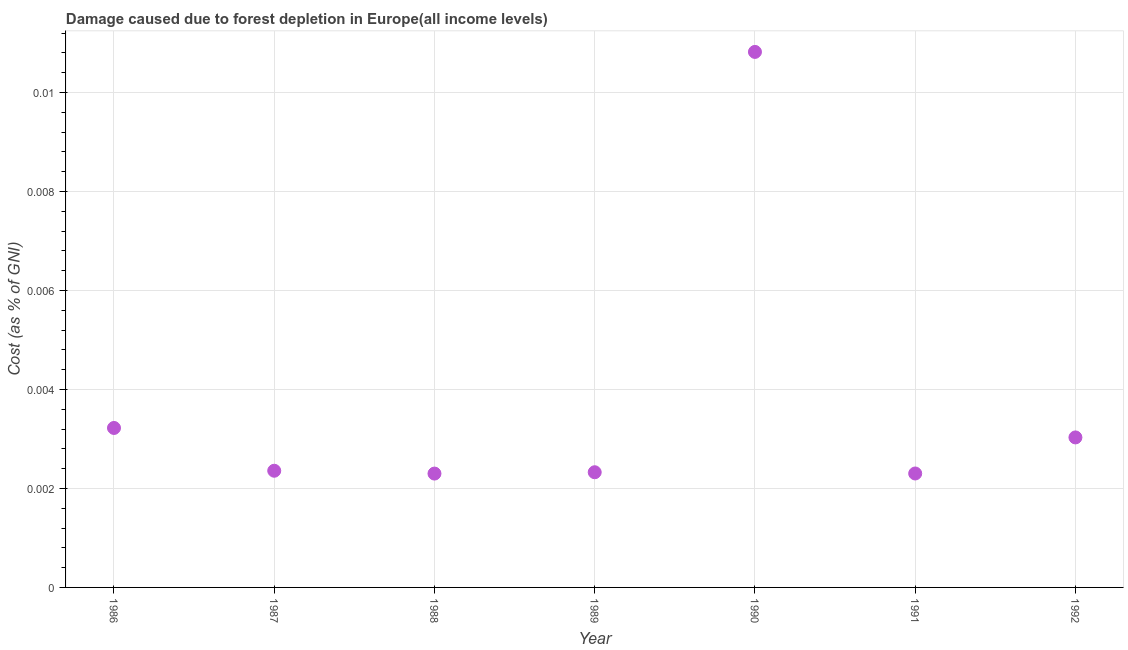What is the damage caused due to forest depletion in 1986?
Your answer should be compact. 0. Across all years, what is the maximum damage caused due to forest depletion?
Give a very brief answer. 0.01. Across all years, what is the minimum damage caused due to forest depletion?
Your response must be concise. 0. In which year was the damage caused due to forest depletion minimum?
Offer a terse response. 1988. What is the sum of the damage caused due to forest depletion?
Your answer should be compact. 0.03. What is the difference between the damage caused due to forest depletion in 1987 and 1991?
Keep it short and to the point. 5.546232632552004e-5. What is the average damage caused due to forest depletion per year?
Provide a succinct answer. 0. What is the median damage caused due to forest depletion?
Provide a short and direct response. 0. What is the ratio of the damage caused due to forest depletion in 1986 to that in 1987?
Your response must be concise. 1.37. What is the difference between the highest and the second highest damage caused due to forest depletion?
Keep it short and to the point. 0.01. Is the sum of the damage caused due to forest depletion in 1986 and 1988 greater than the maximum damage caused due to forest depletion across all years?
Offer a terse response. No. What is the difference between the highest and the lowest damage caused due to forest depletion?
Offer a very short reply. 0.01. How many dotlines are there?
Your answer should be very brief. 1. How many years are there in the graph?
Provide a succinct answer. 7. What is the difference between two consecutive major ticks on the Y-axis?
Your answer should be very brief. 0. Are the values on the major ticks of Y-axis written in scientific E-notation?
Keep it short and to the point. No. Does the graph contain any zero values?
Your response must be concise. No. Does the graph contain grids?
Keep it short and to the point. Yes. What is the title of the graph?
Ensure brevity in your answer.  Damage caused due to forest depletion in Europe(all income levels). What is the label or title of the X-axis?
Offer a terse response. Year. What is the label or title of the Y-axis?
Keep it short and to the point. Cost (as % of GNI). What is the Cost (as % of GNI) in 1986?
Provide a succinct answer. 0. What is the Cost (as % of GNI) in 1987?
Offer a terse response. 0. What is the Cost (as % of GNI) in 1988?
Make the answer very short. 0. What is the Cost (as % of GNI) in 1989?
Provide a short and direct response. 0. What is the Cost (as % of GNI) in 1990?
Provide a short and direct response. 0.01. What is the Cost (as % of GNI) in 1991?
Your answer should be very brief. 0. What is the Cost (as % of GNI) in 1992?
Give a very brief answer. 0. What is the difference between the Cost (as % of GNI) in 1986 and 1987?
Your response must be concise. 0. What is the difference between the Cost (as % of GNI) in 1986 and 1988?
Give a very brief answer. 0. What is the difference between the Cost (as % of GNI) in 1986 and 1989?
Give a very brief answer. 0. What is the difference between the Cost (as % of GNI) in 1986 and 1990?
Offer a very short reply. -0.01. What is the difference between the Cost (as % of GNI) in 1986 and 1991?
Your response must be concise. 0. What is the difference between the Cost (as % of GNI) in 1986 and 1992?
Your answer should be very brief. 0. What is the difference between the Cost (as % of GNI) in 1987 and 1988?
Your answer should be compact. 6e-5. What is the difference between the Cost (as % of GNI) in 1987 and 1989?
Make the answer very short. 3e-5. What is the difference between the Cost (as % of GNI) in 1987 and 1990?
Make the answer very short. -0.01. What is the difference between the Cost (as % of GNI) in 1987 and 1991?
Offer a terse response. 6e-5. What is the difference between the Cost (as % of GNI) in 1987 and 1992?
Provide a succinct answer. -0. What is the difference between the Cost (as % of GNI) in 1988 and 1989?
Your response must be concise. -3e-5. What is the difference between the Cost (as % of GNI) in 1988 and 1990?
Your answer should be compact. -0.01. What is the difference between the Cost (as % of GNI) in 1988 and 1992?
Provide a short and direct response. -0. What is the difference between the Cost (as % of GNI) in 1989 and 1990?
Make the answer very short. -0.01. What is the difference between the Cost (as % of GNI) in 1989 and 1991?
Keep it short and to the point. 3e-5. What is the difference between the Cost (as % of GNI) in 1989 and 1992?
Ensure brevity in your answer.  -0. What is the difference between the Cost (as % of GNI) in 1990 and 1991?
Provide a short and direct response. 0.01. What is the difference between the Cost (as % of GNI) in 1990 and 1992?
Ensure brevity in your answer.  0.01. What is the difference between the Cost (as % of GNI) in 1991 and 1992?
Offer a very short reply. -0. What is the ratio of the Cost (as % of GNI) in 1986 to that in 1987?
Your response must be concise. 1.37. What is the ratio of the Cost (as % of GNI) in 1986 to that in 1988?
Offer a very short reply. 1.4. What is the ratio of the Cost (as % of GNI) in 1986 to that in 1989?
Your response must be concise. 1.39. What is the ratio of the Cost (as % of GNI) in 1986 to that in 1990?
Provide a short and direct response. 0.3. What is the ratio of the Cost (as % of GNI) in 1986 to that in 1991?
Provide a succinct answer. 1.4. What is the ratio of the Cost (as % of GNI) in 1986 to that in 1992?
Your answer should be very brief. 1.06. What is the ratio of the Cost (as % of GNI) in 1987 to that in 1988?
Ensure brevity in your answer.  1.02. What is the ratio of the Cost (as % of GNI) in 1987 to that in 1990?
Make the answer very short. 0.22. What is the ratio of the Cost (as % of GNI) in 1987 to that in 1991?
Provide a succinct answer. 1.02. What is the ratio of the Cost (as % of GNI) in 1987 to that in 1992?
Provide a succinct answer. 0.78. What is the ratio of the Cost (as % of GNI) in 1988 to that in 1990?
Offer a terse response. 0.21. What is the ratio of the Cost (as % of GNI) in 1988 to that in 1991?
Give a very brief answer. 1. What is the ratio of the Cost (as % of GNI) in 1988 to that in 1992?
Ensure brevity in your answer.  0.76. What is the ratio of the Cost (as % of GNI) in 1989 to that in 1990?
Your response must be concise. 0.21. What is the ratio of the Cost (as % of GNI) in 1989 to that in 1991?
Your answer should be compact. 1.01. What is the ratio of the Cost (as % of GNI) in 1989 to that in 1992?
Offer a very short reply. 0.77. What is the ratio of the Cost (as % of GNI) in 1990 to that in 1992?
Make the answer very short. 3.57. What is the ratio of the Cost (as % of GNI) in 1991 to that in 1992?
Offer a very short reply. 0.76. 